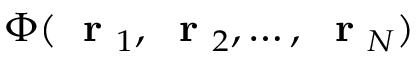Convert formula to latex. <formula><loc_0><loc_0><loc_500><loc_500>\Phi ( r _ { 1 } , r _ { 2 } , \dots , r _ { N } )</formula> 